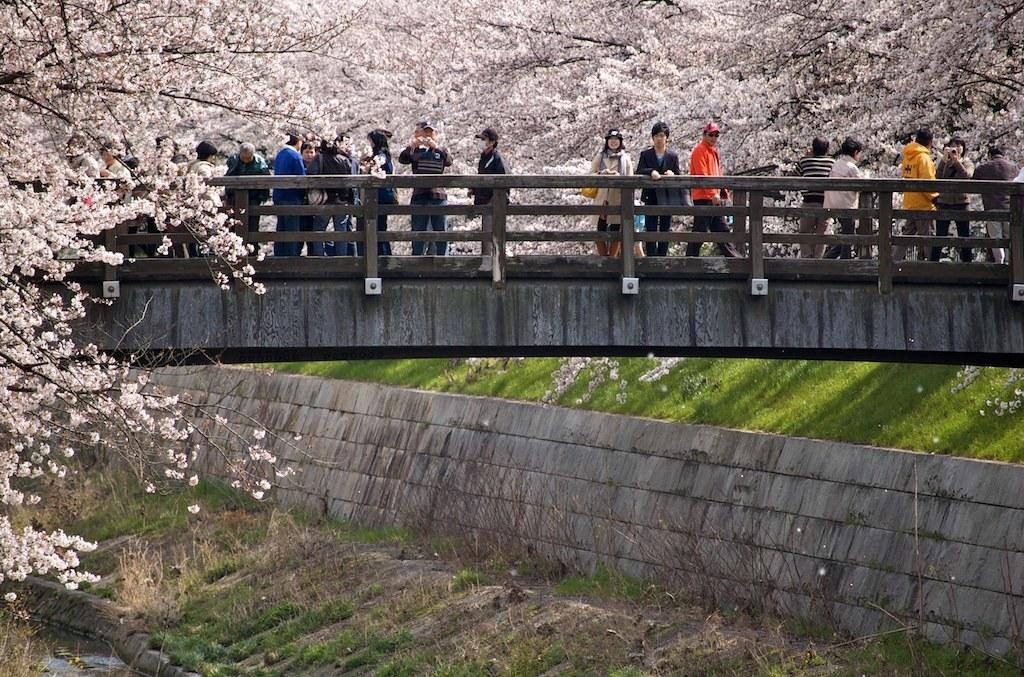What type of vegetation can be seen in the image? There are trees, flowers, branches, grass, and plants visible in the image. What structure can be seen in the image? There is a railing and a bridge visible in the image. Where are the people located in the image? The people are standing on a bridge in the image. What is visible in the bottom left corner of the image? There is water visible in the bottom left corner of the image. What is the profit margin of the competition in the image? There is no mention of profit or competition in the image; it features trees, flowers, branches, grass, plants, a railing, a bridge, people, and water. 